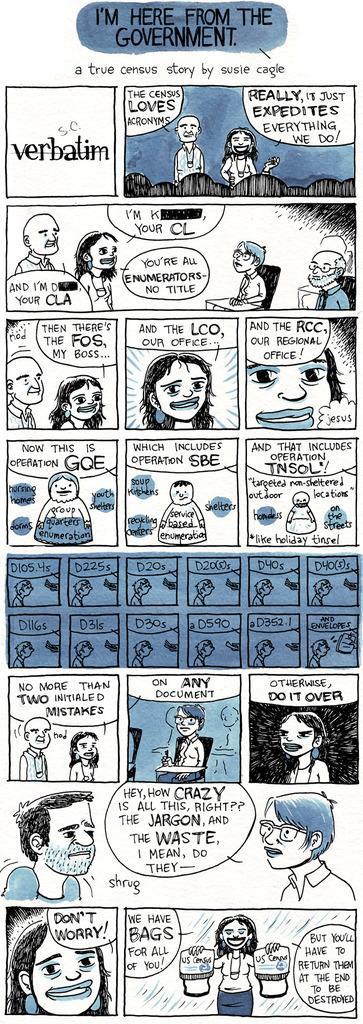Please provide a concise description of this image. In the picture I can see cartoon images of people and some other things. I can also see something written on the image. 